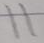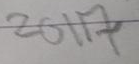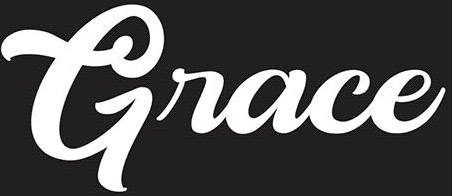Transcribe the words shown in these images in order, separated by a semicolon. 11; 2017; Grace 